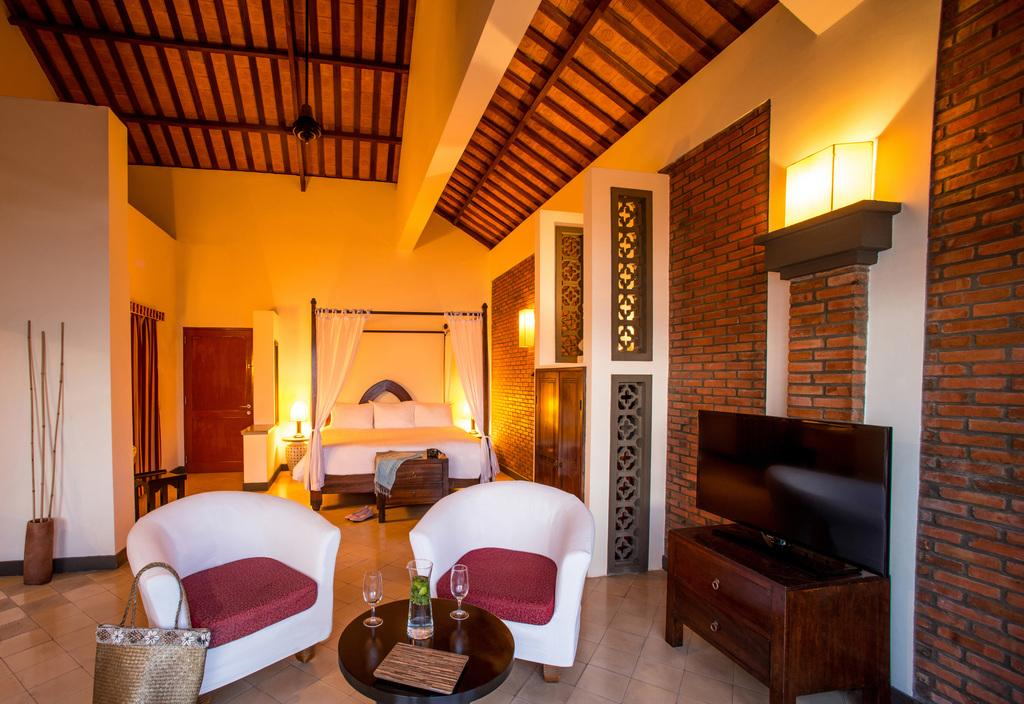What type of accessory is visible in the image? There is a handbag in the image. What type of furniture is present in the image? There are two couches, a table, a television, and a bed in the image. What objects are on the table in the image? There are glasses on a table in the image. What type of lighting is visible in the image? There are lights visible in the image. How many vases are present on the couches in the image? There are no vases present on the couches in the image. Can you tell me how many passengers are sitting on the bed in the image? There are no passengers present in the image, as it is a still image and not a scene with people. 